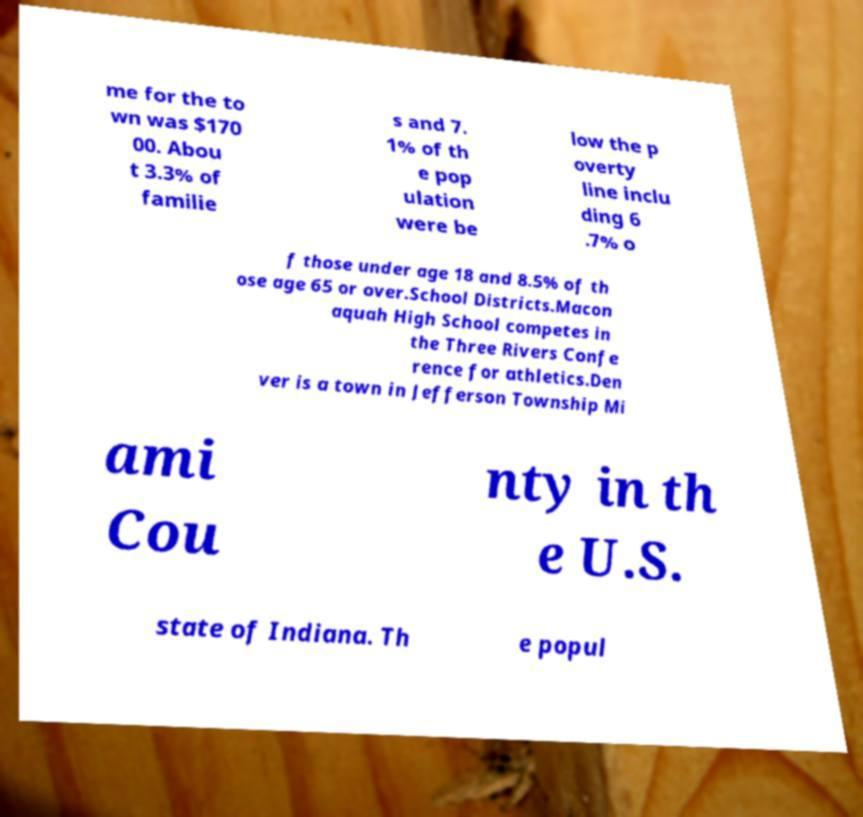Can you accurately transcribe the text from the provided image for me? me for the to wn was $170 00. Abou t 3.3% of familie s and 7. 1% of th e pop ulation were be low the p overty line inclu ding 6 .7% o f those under age 18 and 8.5% of th ose age 65 or over.School Districts.Macon aquah High School competes in the Three Rivers Confe rence for athletics.Den ver is a town in Jefferson Township Mi ami Cou nty in th e U.S. state of Indiana. Th e popul 